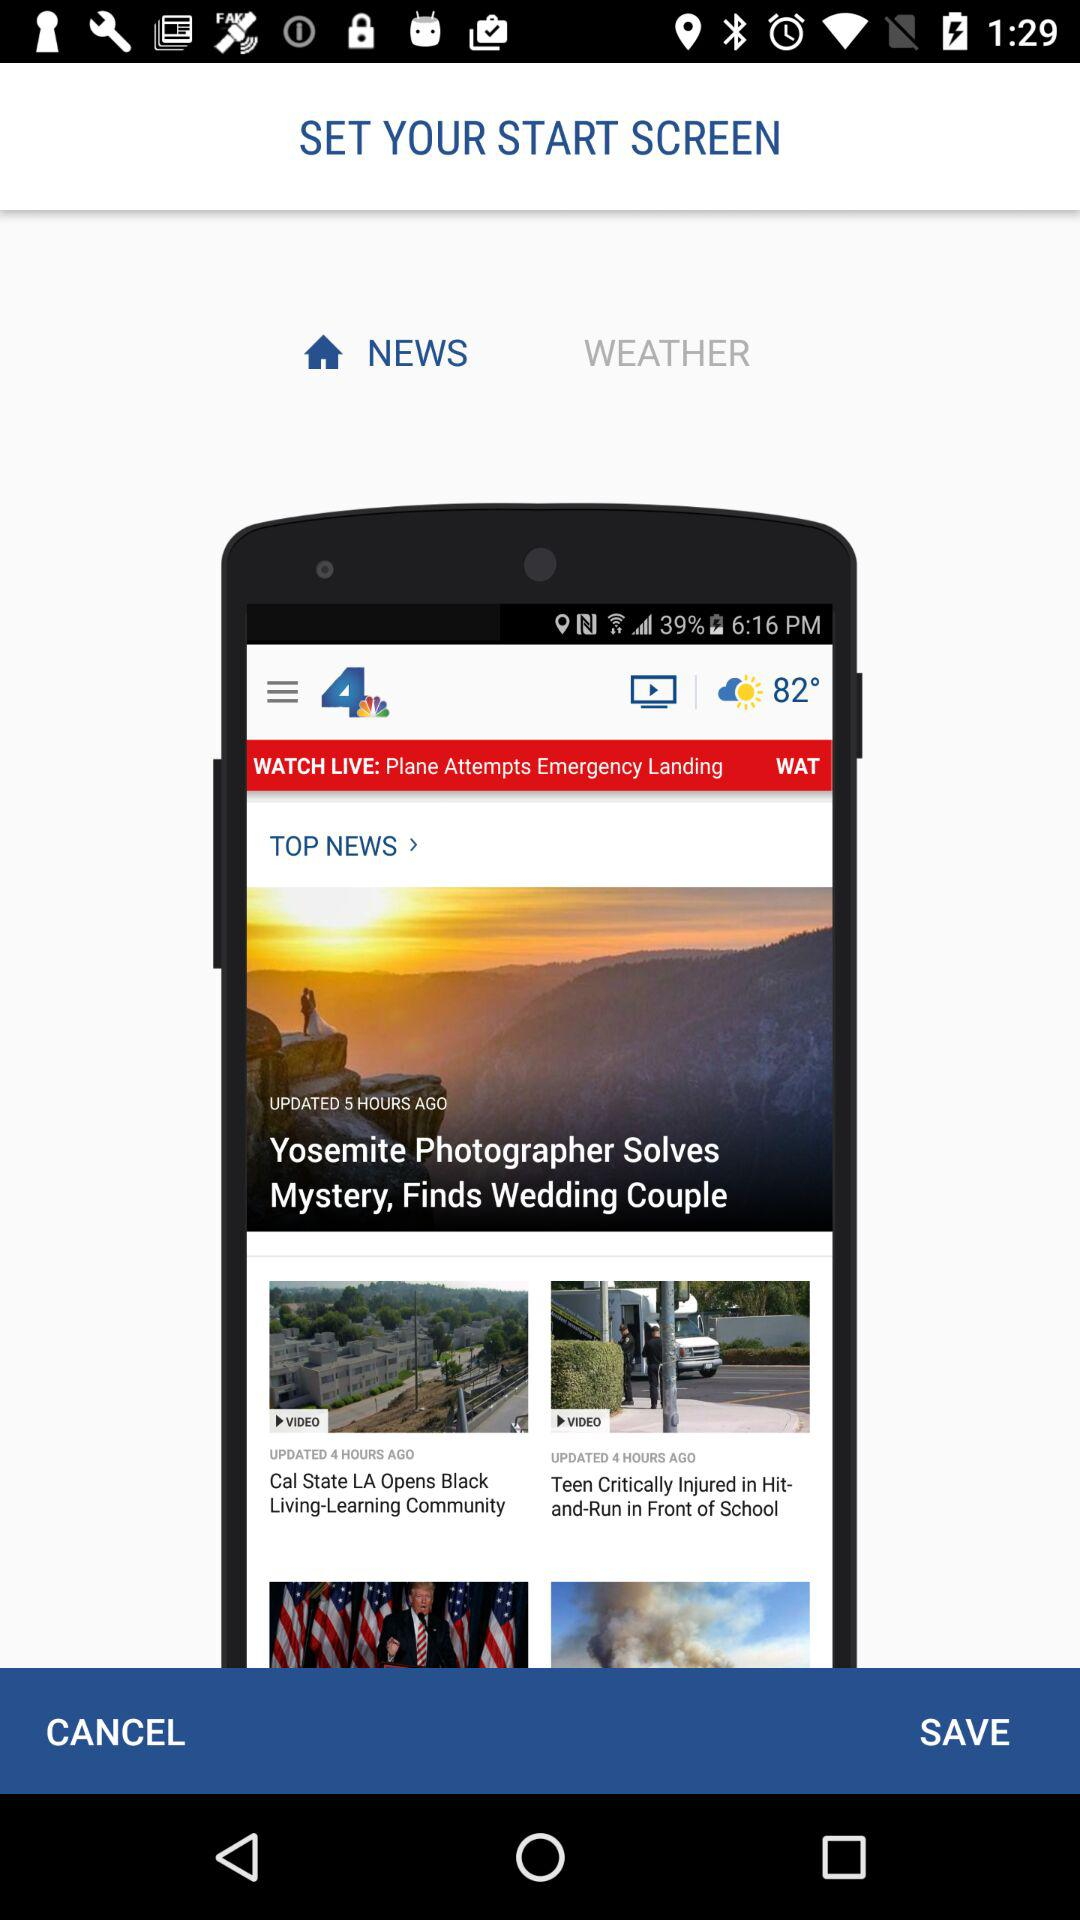Which option is selected in "SET YOUR START SCREEN"? The option that is selected in "SET YOUR START SCREEN" is "NEWS". 